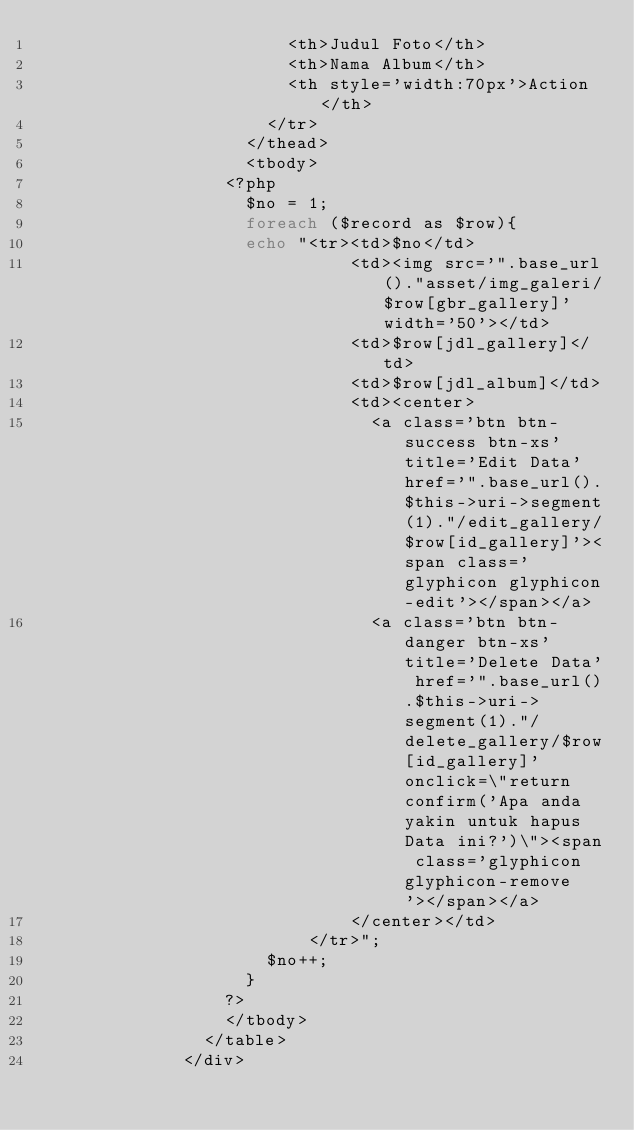<code> <loc_0><loc_0><loc_500><loc_500><_PHP_>                        <th>Judul Foto</th>
                        <th>Nama Album</th>
                        <th style='width:70px'>Action</th>
                      </tr>
                    </thead>
                    <tbody>
                  <?php 
                    $no = 1;
                    foreach ($record as $row){
                    echo "<tr><td>$no</td>
                              <td><img src='".base_url()."asset/img_galeri/$row[gbr_gallery]' width='50'></td>
                              <td>$row[jdl_gallery]</td>
                              <td>$row[jdl_album]</td>
                              <td><center>
                                <a class='btn btn-success btn-xs' title='Edit Data' href='".base_url().$this->uri->segment(1)."/edit_gallery/$row[id_gallery]'><span class='glyphicon glyphicon-edit'></span></a>
                                <a class='btn btn-danger btn-xs' title='Delete Data' href='".base_url().$this->uri->segment(1)."/delete_gallery/$row[id_gallery]' onclick=\"return confirm('Apa anda yakin untuk hapus Data ini?')\"><span class='glyphicon glyphicon-remove'></span></a>
                              </center></td>
                          </tr>";
                      $no++;
                    }
                  ?>
                  </tbody>
                </table>
              </div></code> 